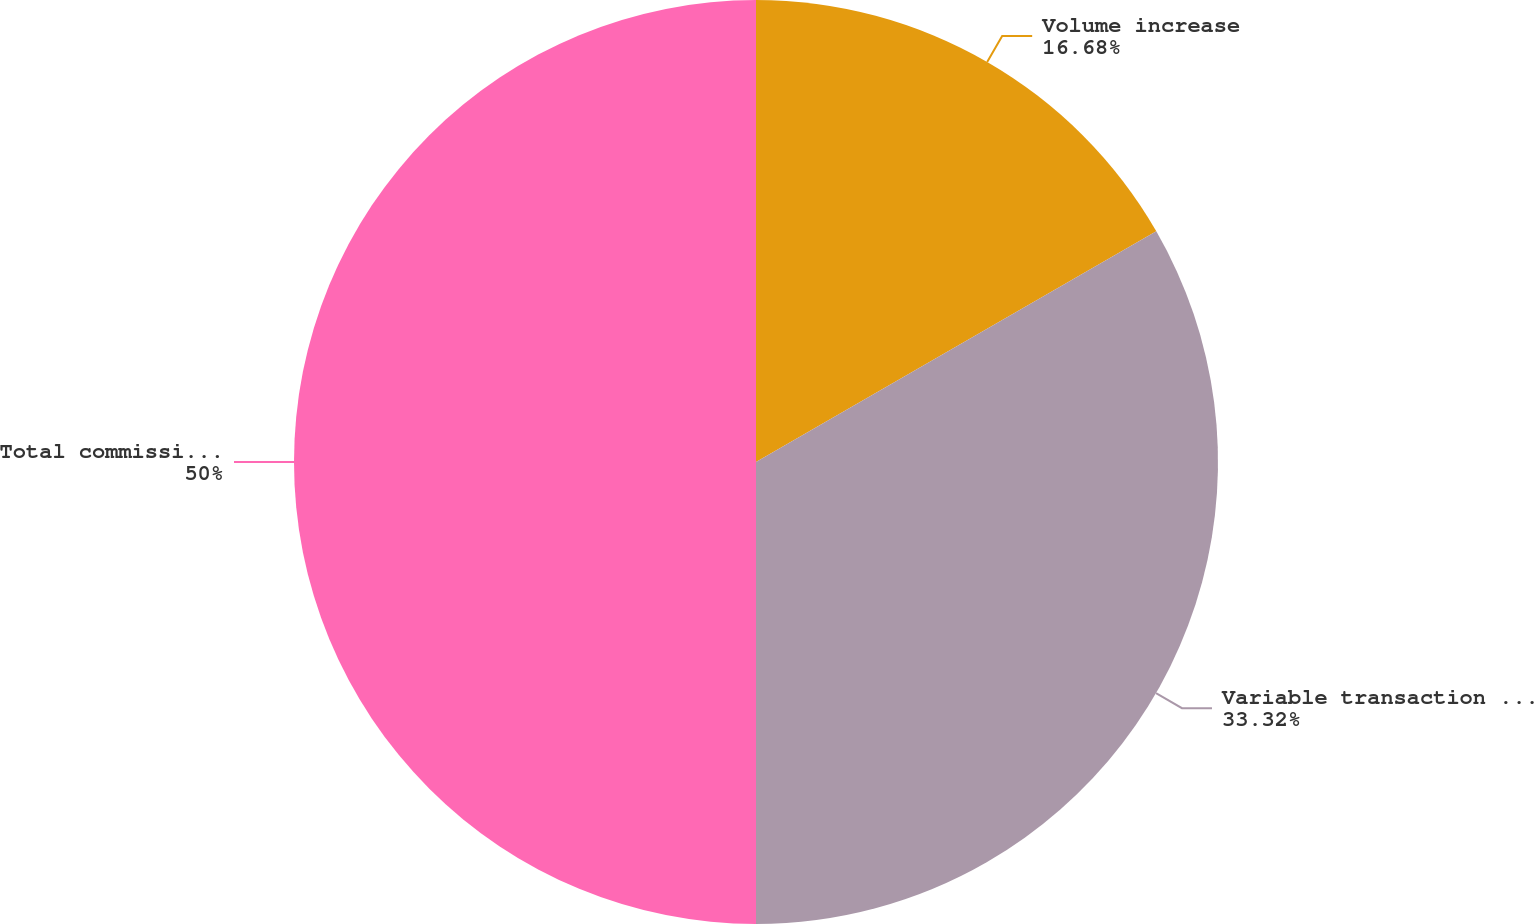<chart> <loc_0><loc_0><loc_500><loc_500><pie_chart><fcel>Volume increase<fcel>Variable transaction fee per<fcel>Total commissions increase<nl><fcel>16.68%<fcel>33.32%<fcel>50.0%<nl></chart> 